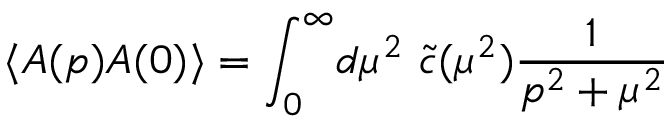Convert formula to latex. <formula><loc_0><loc_0><loc_500><loc_500>\langle A ( p ) A ( 0 ) \rangle = \int _ { 0 } ^ { \infty } \, d \mu ^ { 2 } \ \tilde { c } ( \mu ^ { 2 } ) \frac { 1 } { p ^ { 2 } + \mu ^ { 2 } }</formula> 